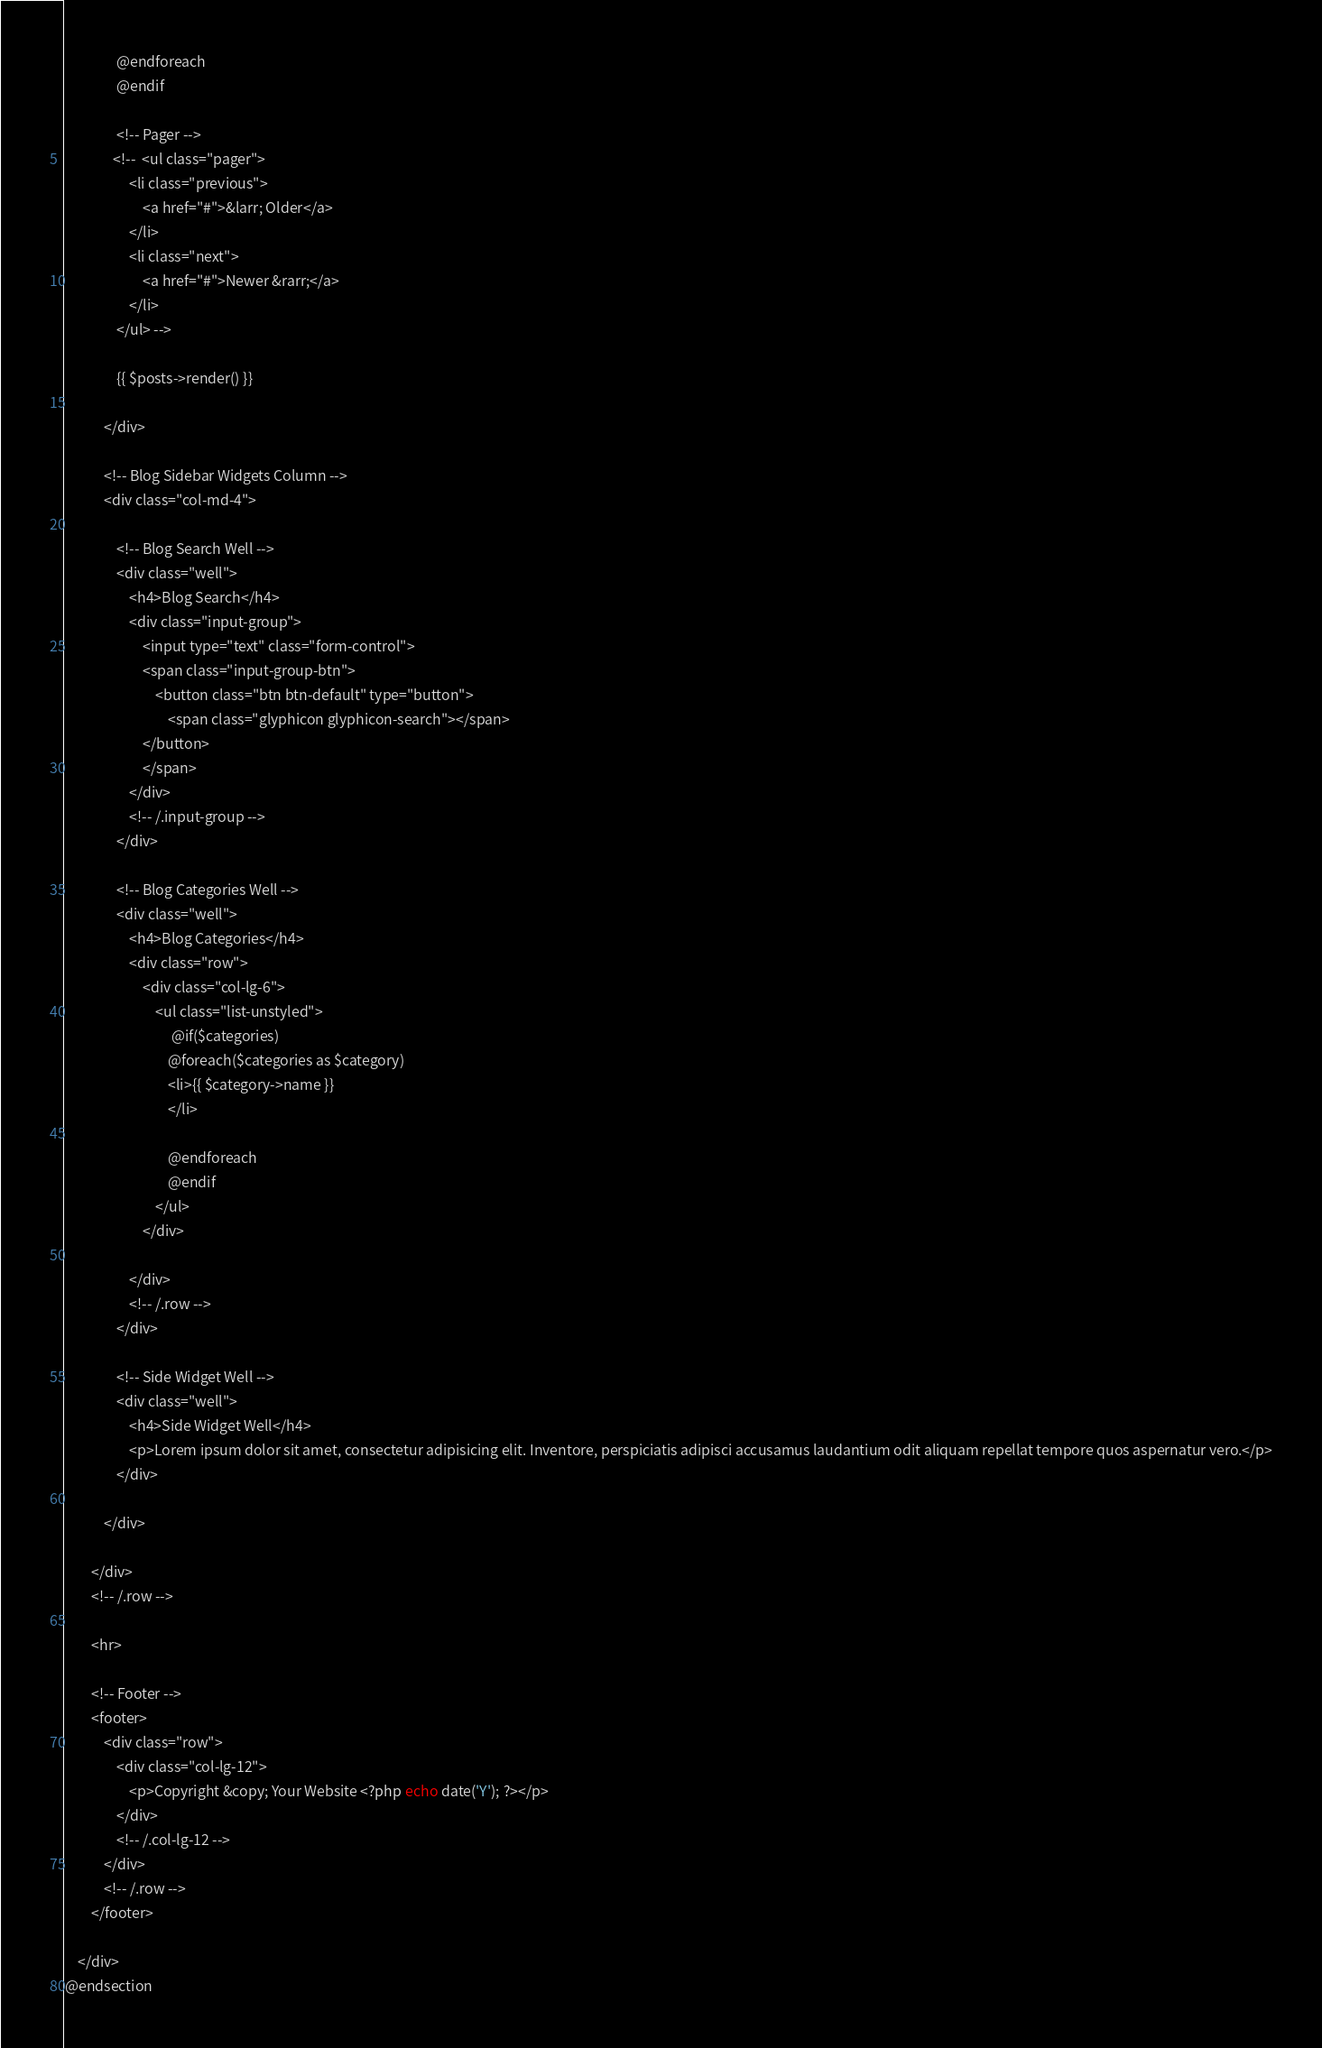Convert code to text. <code><loc_0><loc_0><loc_500><loc_500><_PHP_>                @endforeach
                @endif
                
                <!-- Pager -->
               <!--  <ul class="pager">
                    <li class="previous">
                        <a href="#">&larr; Older</a>
                    </li>
                    <li class="next">
                        <a href="#">Newer &rarr;</a>
                    </li>
                </ul> -->

                {{ $posts->render() }}

            </div>

            <!-- Blog Sidebar Widgets Column -->
            <div class="col-md-4">

                <!-- Blog Search Well -->
                <div class="well">
                    <h4>Blog Search</h4>
                    <div class="input-group">
                        <input type="text" class="form-control">
                        <span class="input-group-btn">
                            <button class="btn btn-default" type="button">
                                <span class="glyphicon glyphicon-search"></span>
                        </button>
                        </span>
                    </div>
                    <!-- /.input-group -->
                </div>

                <!-- Blog Categories Well -->
                <div class="well">
                    <h4>Blog Categories</h4>
                    <div class="row">
                        <div class="col-lg-6">
                            <ul class="list-unstyled">
                                 @if($categories)
                                @foreach($categories as $category)
                                <li>{{ $category->name }}
                                </li>
                                
                                @endforeach
                                @endif
                            </ul>
                        </div>
                       
                    </div>
                    <!-- /.row -->
                </div>

                <!-- Side Widget Well -->
                <div class="well">
                    <h4>Side Widget Well</h4>
                    <p>Lorem ipsum dolor sit amet, consectetur adipisicing elit. Inventore, perspiciatis adipisci accusamus laudantium odit aliquam repellat tempore quos aspernatur vero.</p>
                </div>

            </div>

        </div>
        <!-- /.row -->

        <hr>

        <!-- Footer -->
        <footer>
            <div class="row">
                <div class="col-lg-12">
                    <p>Copyright &copy; Your Website <?php echo date('Y'); ?></p>
                </div>
                <!-- /.col-lg-12 -->
            </div>
            <!-- /.row -->
        </footer>

    </div>
@endsection
</code> 